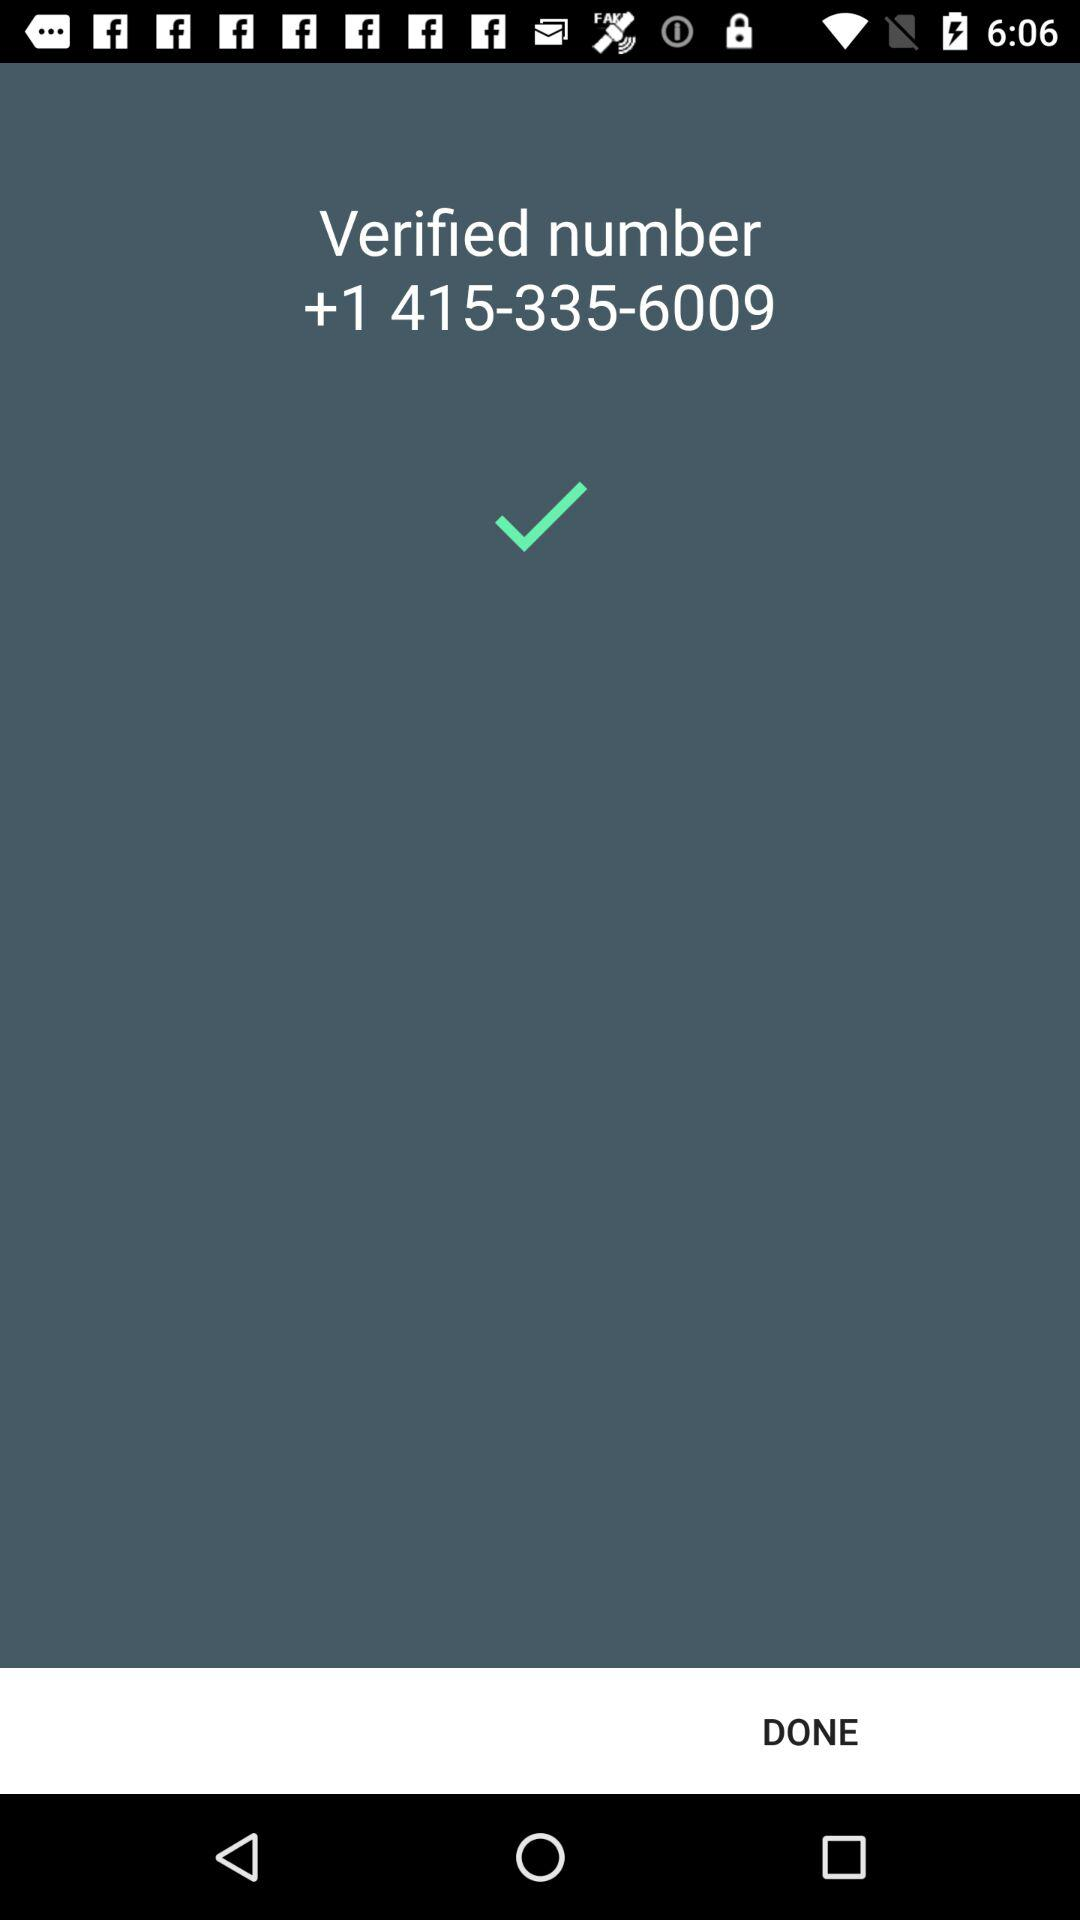What is the verified number? The verified number is +1 415-335-6009. 